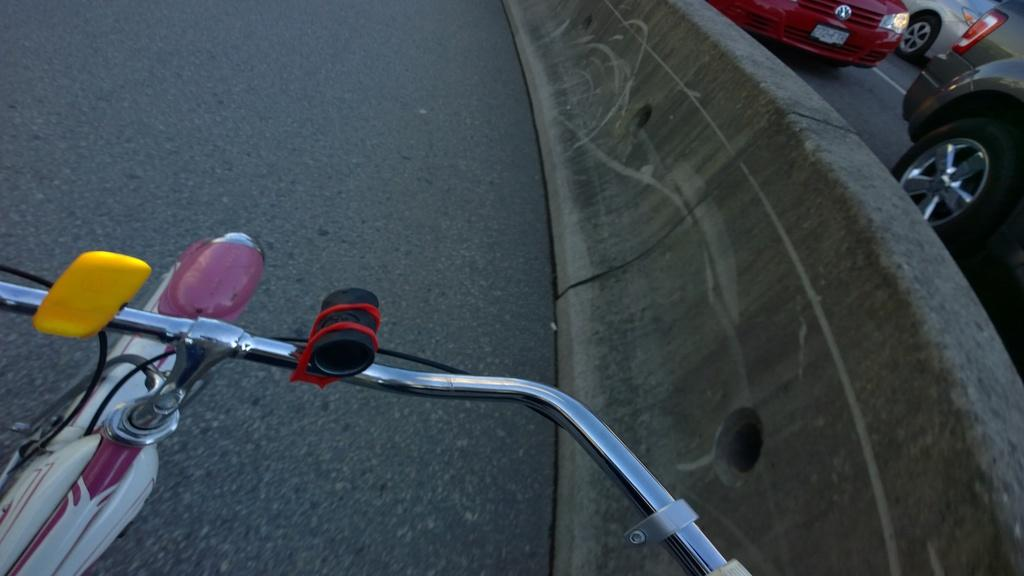What object is located at the bottom of the image? There is a handle of a cycle at the bottom of the image. What can be seen on the right side of the image? There are vehicles moving on the road on the right side of the image. What separates the two sides of the image? There is a divider in the middle of the image. What type of discussion is taking place between the vehicles in the image? There is no discussion taking place between the vehicles in the image; they are simply moving on the road. 